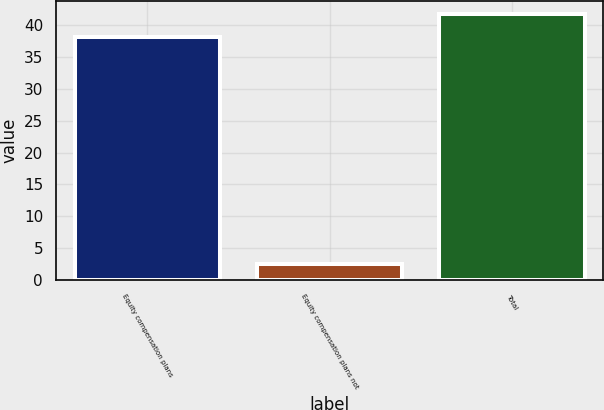Convert chart. <chart><loc_0><loc_0><loc_500><loc_500><bar_chart><fcel>Equity compensation plans<fcel>Equity compensation plans not<fcel>Total<nl><fcel>38.14<fcel>2.51<fcel>41.7<nl></chart> 